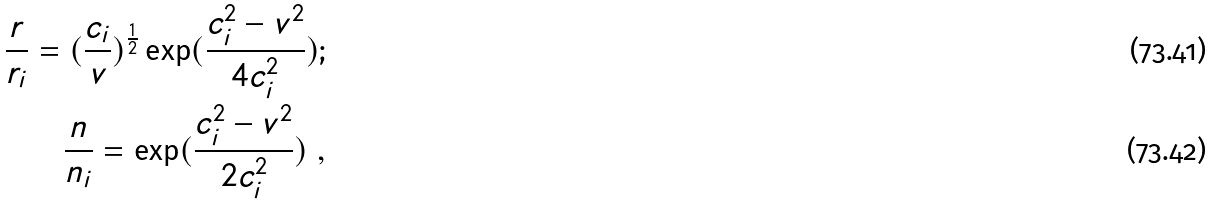Convert formula to latex. <formula><loc_0><loc_0><loc_500><loc_500>\frac { r } { r _ { i } } = ( \frac { c _ { i } } { v } ) ^ { \frac { 1 } { 2 } } \exp ( \frac { c _ { i } ^ { 2 } - v ^ { 2 } } { 4 c _ { i } ^ { 2 } } ) ; \\ \frac { n } { n _ { i } } = \exp ( \frac { c _ { i } ^ { 2 } - v ^ { 2 } } { 2 c _ { i } ^ { 2 } } ) \ ,</formula> 